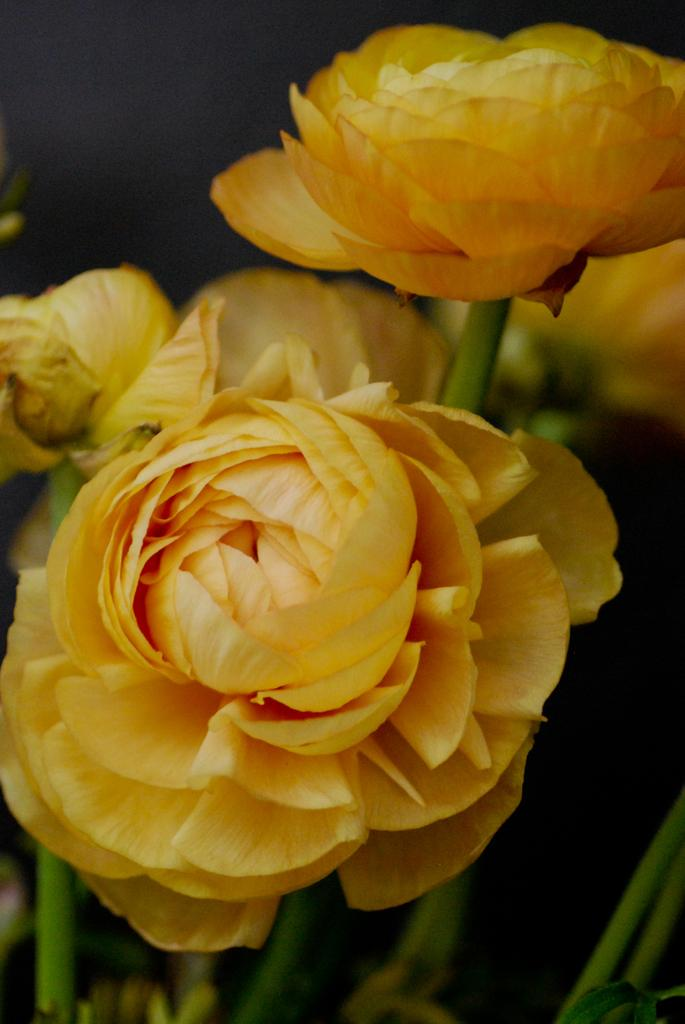What type of flowers can be seen in the foreground of the image? There are yellow flowers in the foreground of the image. Can you describe any other parts of the flowers besides the petals? Yes, the stems of the flowers are visible. What type of bun is being used to hold the language in the image? There is no bun or language present in the image; it features yellow flowers and their stems. 